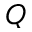Convert formula to latex. <formula><loc_0><loc_0><loc_500><loc_500>Q</formula> 